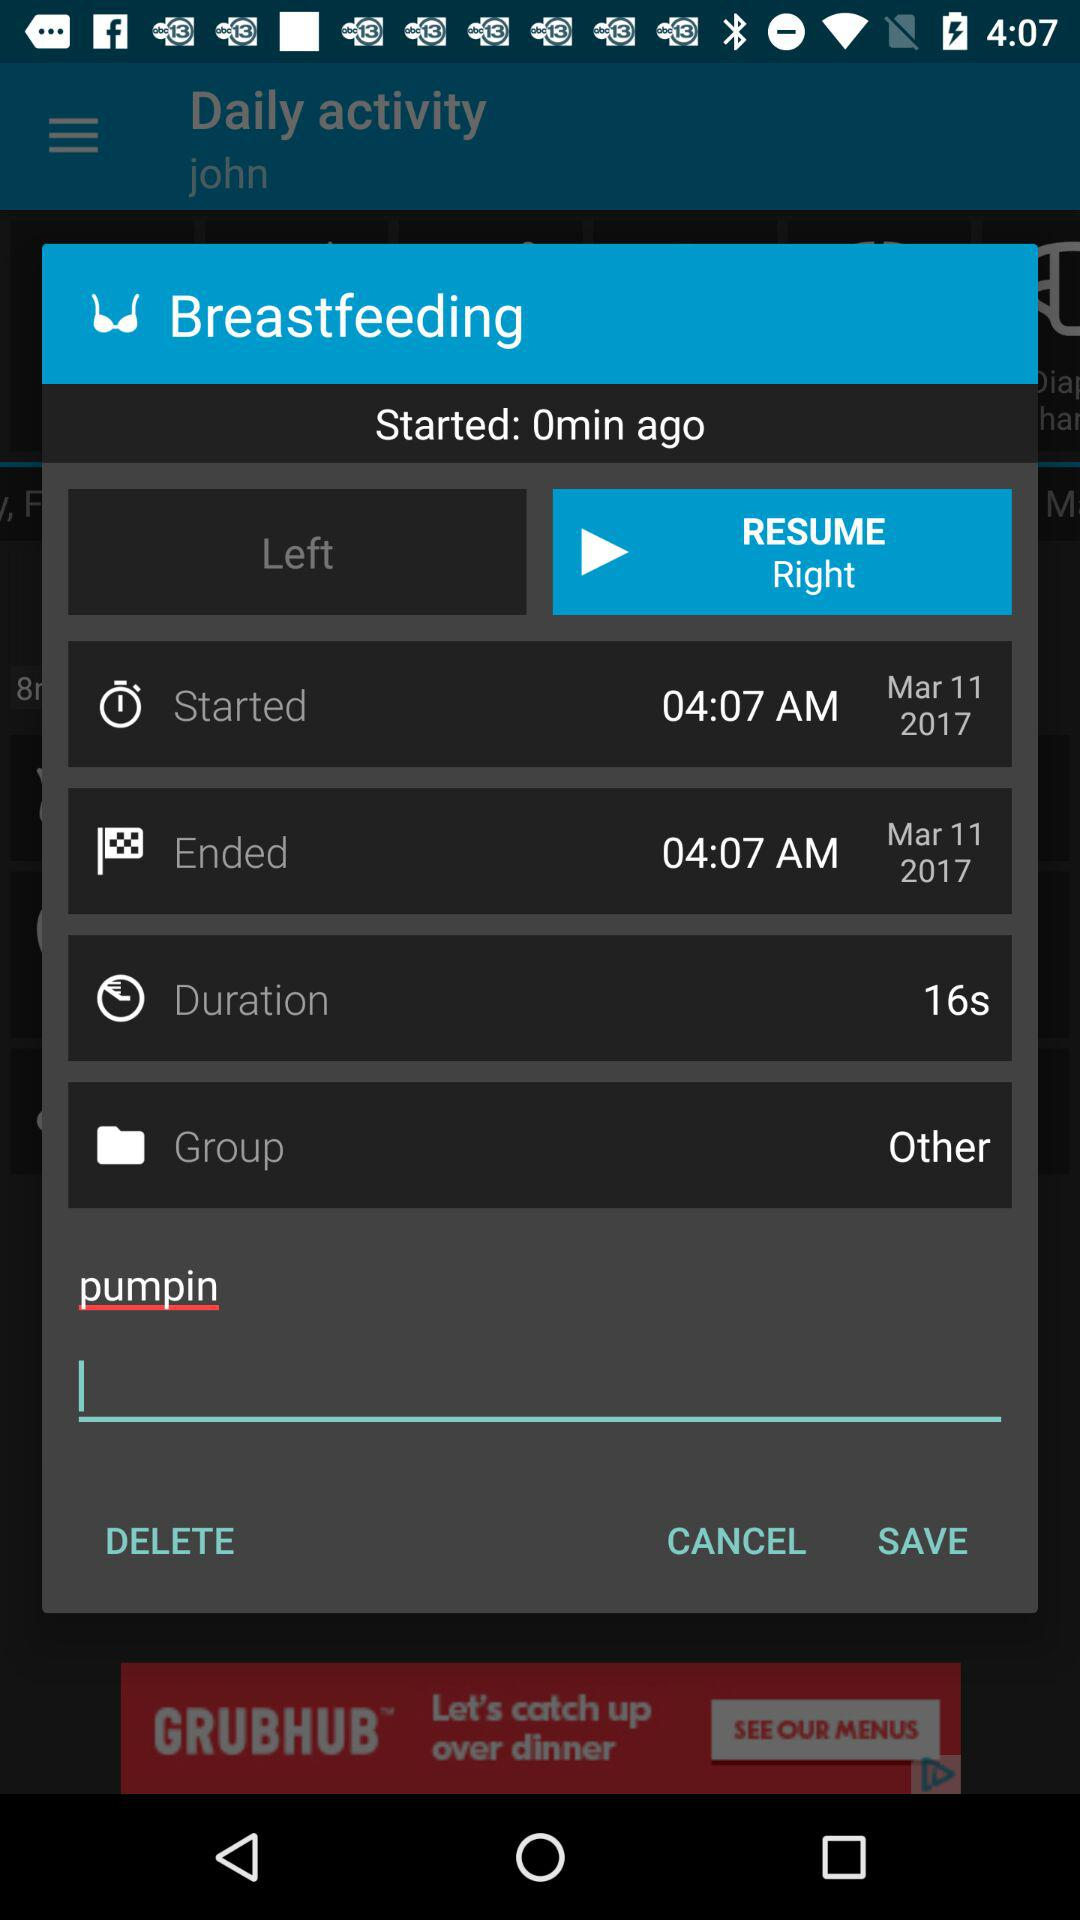When was breastfeeding started? Breastfeeding was started on March 11, 2017 at 4:07 AM. 